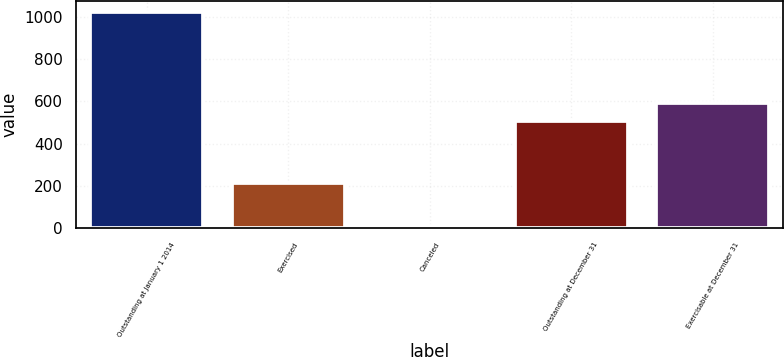<chart> <loc_0><loc_0><loc_500><loc_500><bar_chart><fcel>Outstanding at January 1 2014<fcel>Exercised<fcel>Canceled<fcel>Outstanding at December 31<fcel>Exercisable at December 31<nl><fcel>1026<fcel>213<fcel>10<fcel>507<fcel>593.5<nl></chart> 